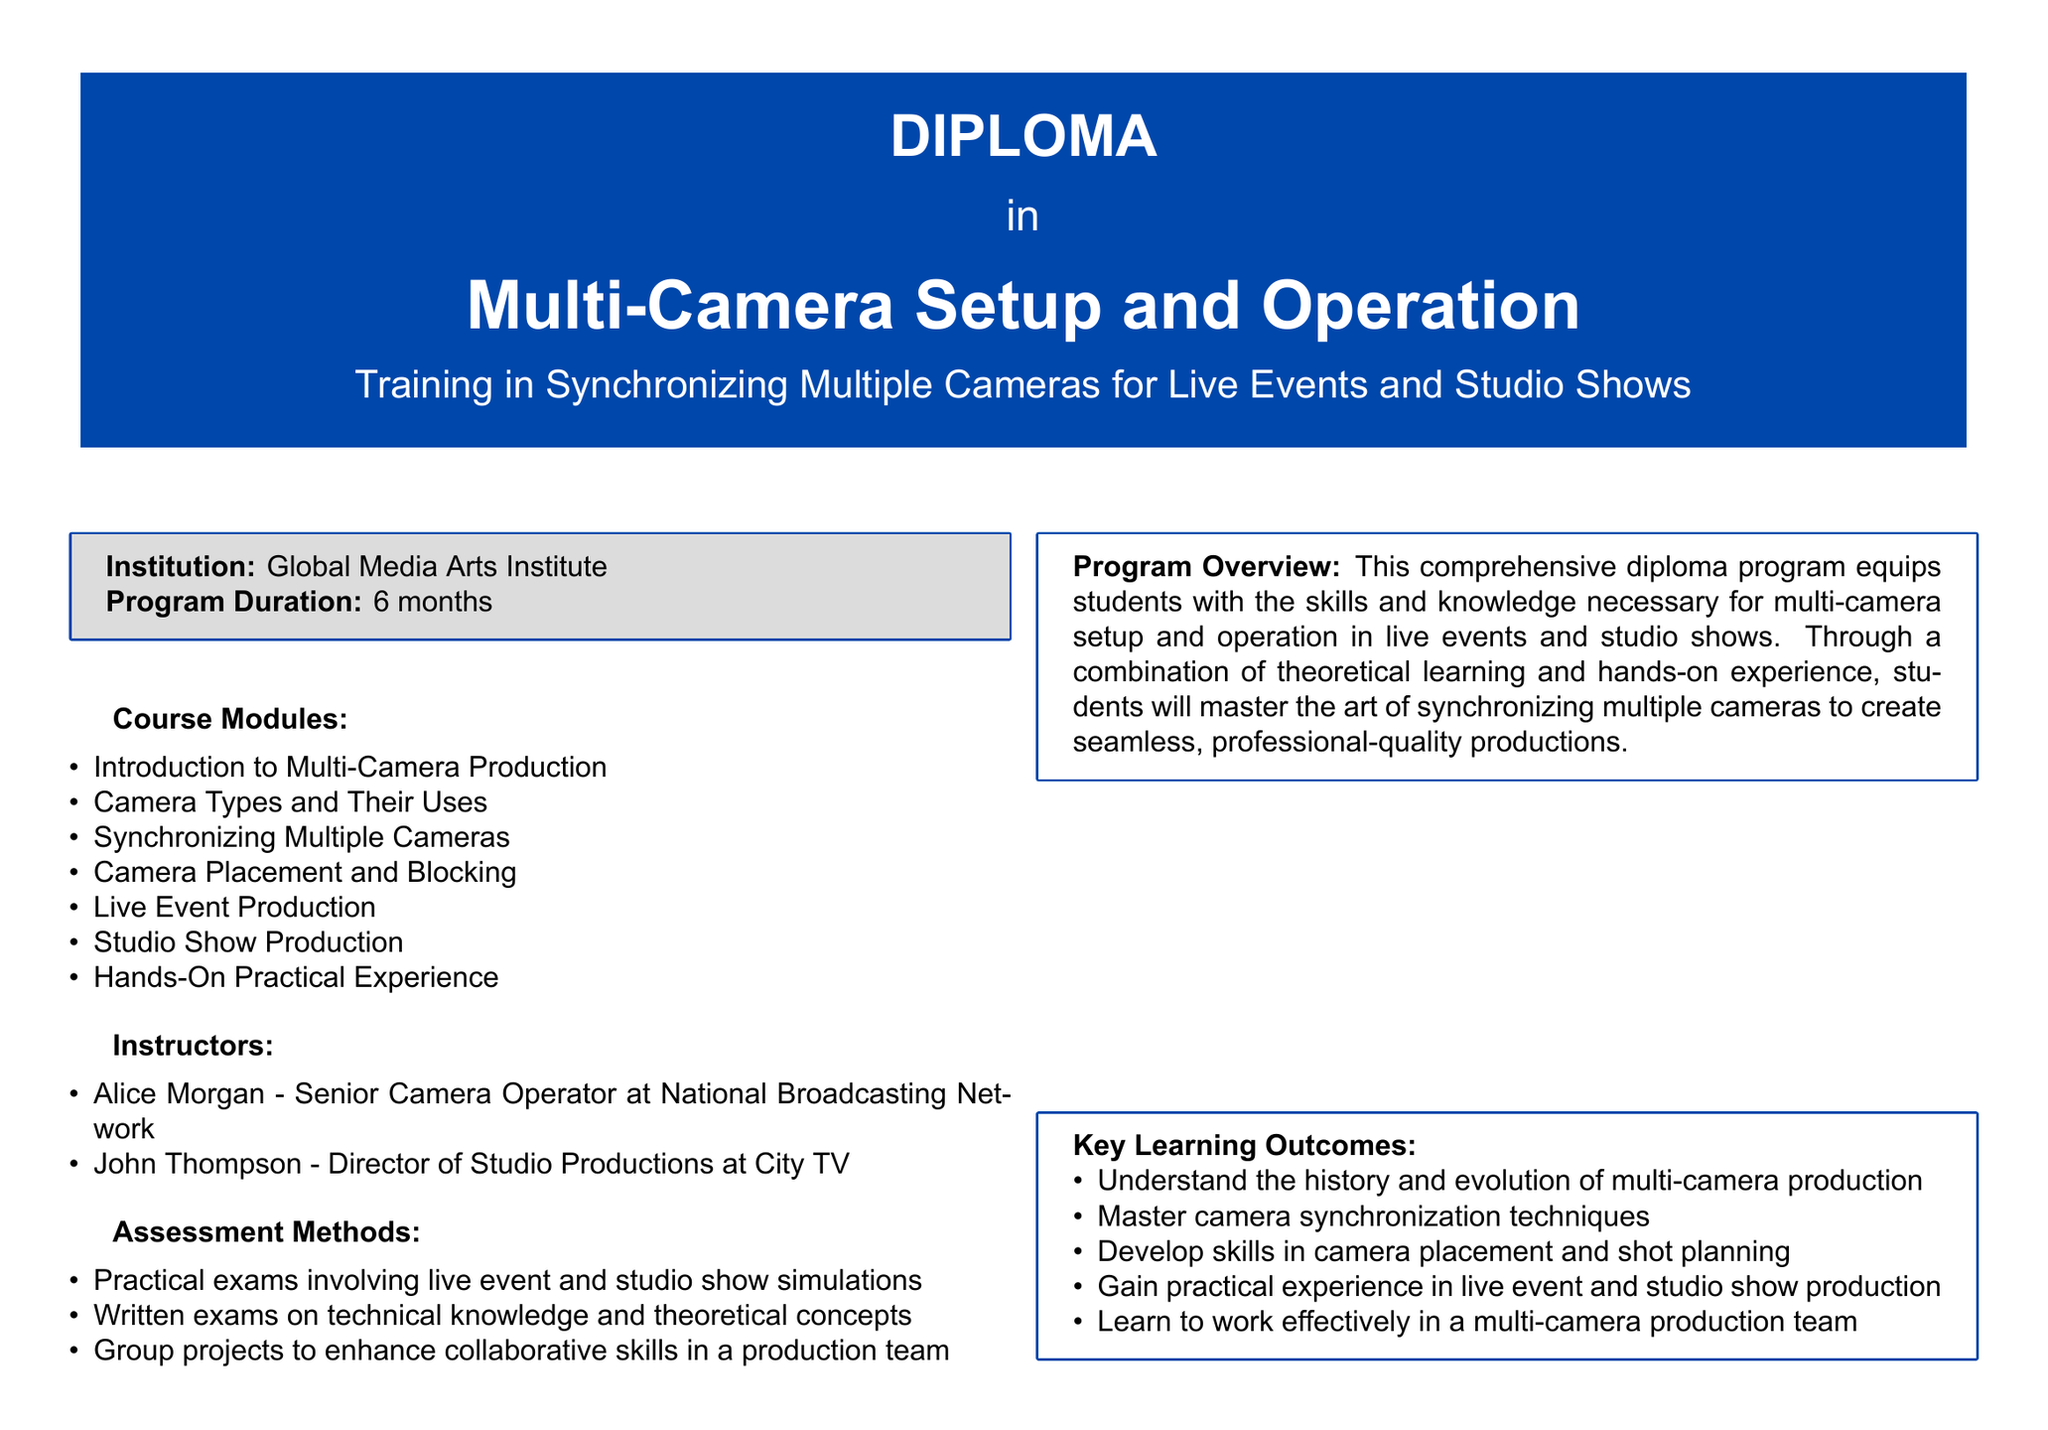What is the name of the institution? The document states that the institution offering the diploma is Global Media Arts Institute.
Answer: Global Media Arts Institute How long is the program duration? The program duration listed in the document is 6 months.
Answer: 6 months Who is one of the instructors? The document provides the names of instructors, including Alice Morgan, who is a Senior Camera Operator.
Answer: Alice Morgan What is one of the key learning outcomes? The document lists several key learning outcomes, one being the mastery of camera synchronization techniques.
Answer: Master camera synchronization techniques What type of assessment methods are used? The document describes assessment methods including practical exams involving live event and studio show simulations.
Answer: Practical exams What career opportunity is mentioned for graduates? The document outlines several career opportunities, such as Camera Operator for Live Events.
Answer: Camera Operator for Live Events What module covers camera placement and shot planning? The module specifically focusing on that topic is "Camera Placement and Blocking."
Answer: Camera Placement and Blocking What is the main focus of the program overview? The program overview emphasizes equipping students with skills for multi-camera setup and operation in live events and studio shows.
Answer: Multi-camera setup and operation What color is used for the diploma background? The color used for the diploma background indicated in the document is tvblue.
Answer: tvblue 